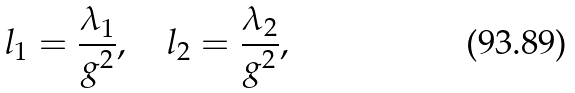<formula> <loc_0><loc_0><loc_500><loc_500>l _ { 1 } = { \frac { \lambda _ { 1 } } { g ^ { 2 } } } , \quad l _ { 2 } = { \frac { \lambda _ { 2 } } { g ^ { 2 } } } ,</formula> 